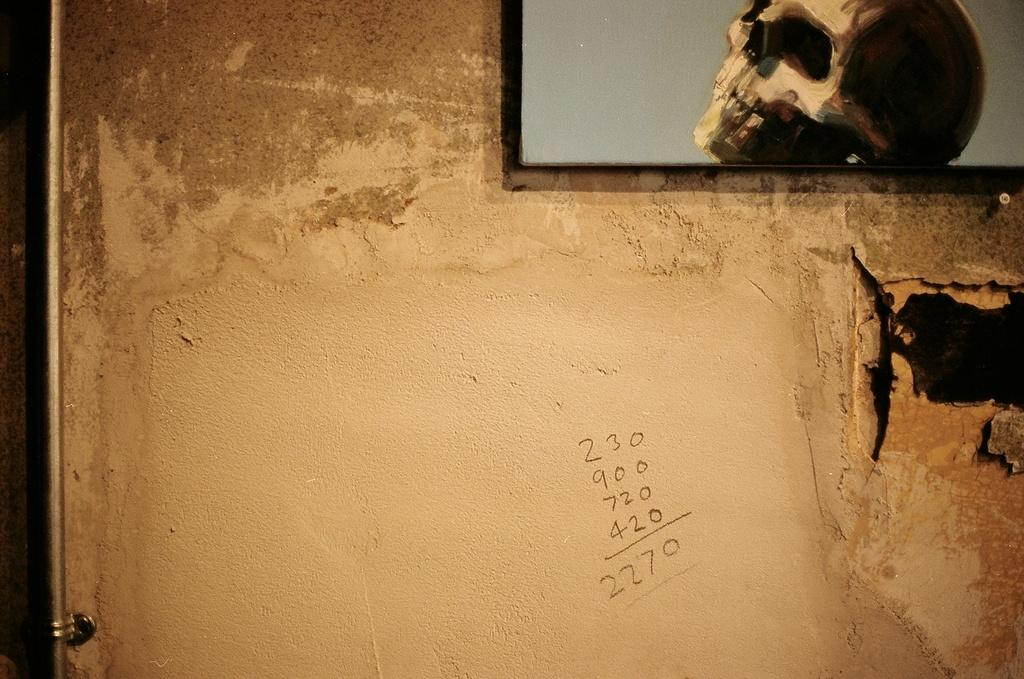What is hanging on the wall in the image? There is a photo frame on the wall. What is located near the photo frame? There is a silver color pipe near the photo frame. What can be seen on the wall besides the photo frame and pipe? There are numbers on the wall. Can you hear a baby whistling in the image? There is no baby or whistling sound present in the image. 